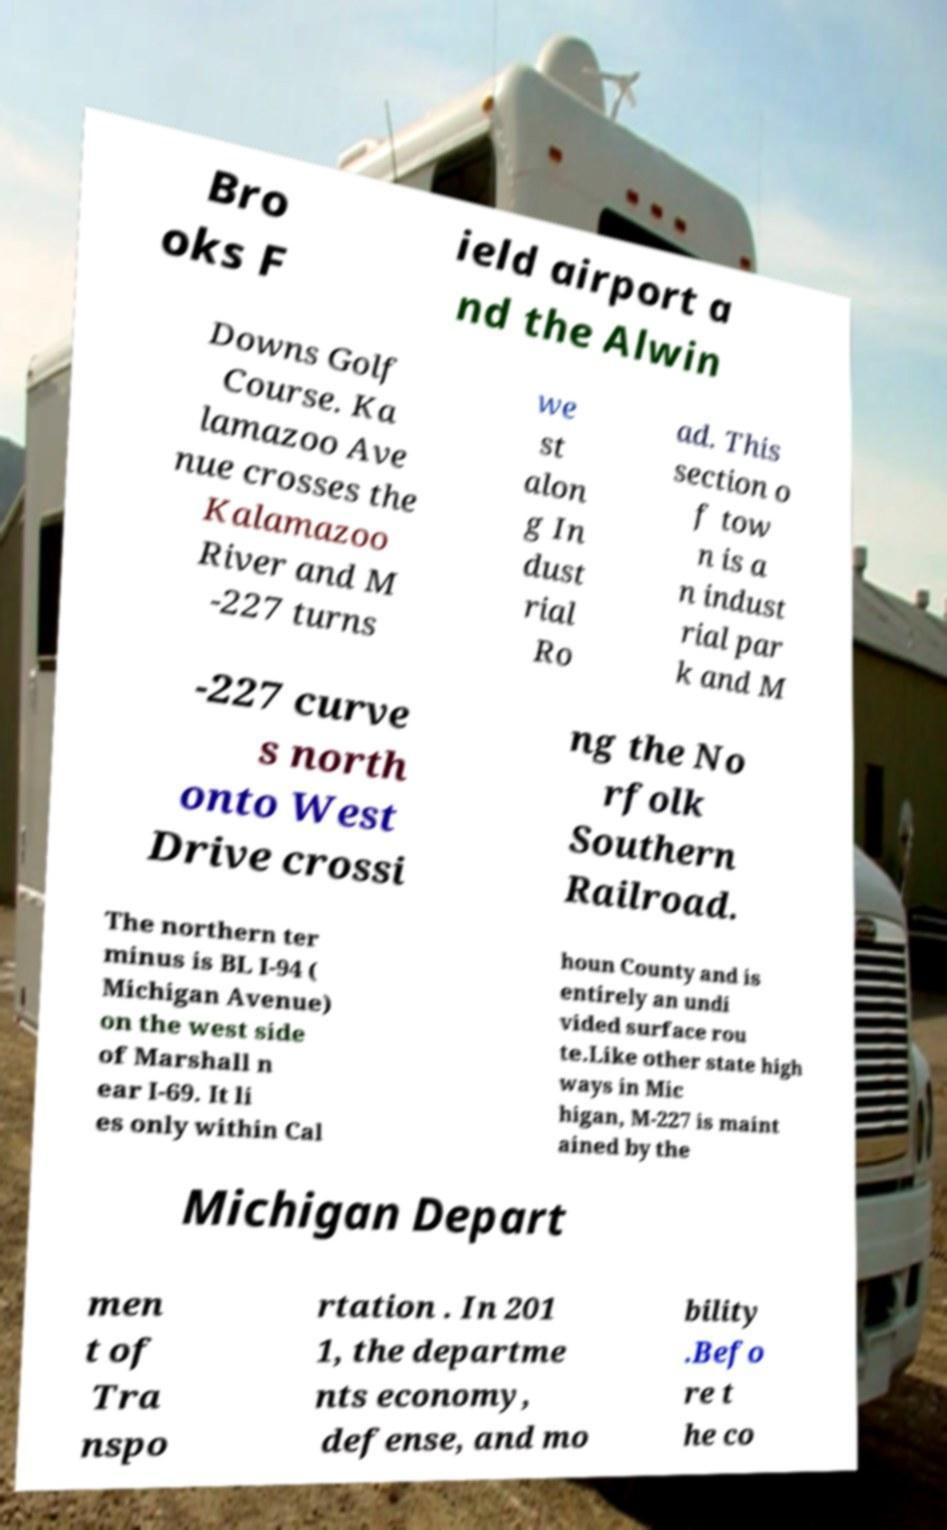For documentation purposes, I need the text within this image transcribed. Could you provide that? Bro oks F ield airport a nd the Alwin Downs Golf Course. Ka lamazoo Ave nue crosses the Kalamazoo River and M -227 turns we st alon g In dust rial Ro ad. This section o f tow n is a n indust rial par k and M -227 curve s north onto West Drive crossi ng the No rfolk Southern Railroad. The northern ter minus is BL I-94 ( Michigan Avenue) on the west side of Marshall n ear I-69. It li es only within Cal houn County and is entirely an undi vided surface rou te.Like other state high ways in Mic higan, M-227 is maint ained by the Michigan Depart men t of Tra nspo rtation . In 201 1, the departme nts economy, defense, and mo bility .Befo re t he co 